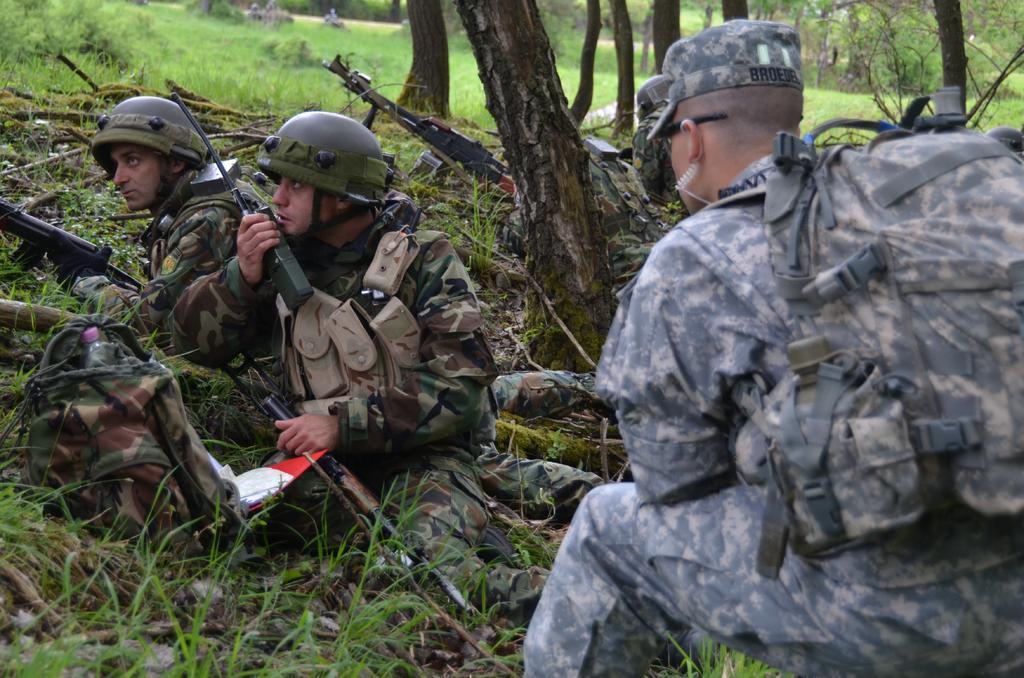Please provide a concise description of this image. This picture shows few people and we see a man laying on the ground and he wore a helmet on his head and holding a gun in his hand and we see another man seated and holding a gun with one hand and walkie-talkie with another hand and we see a backpack and we see another man seated he wore a cap and a backpack on his back and we see couple of them laying on the ground and holding guns and we see trees and grass on the ground. 